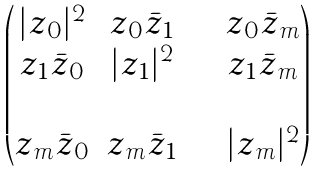Convert formula to latex. <formula><loc_0><loc_0><loc_500><loc_500>\begin{pmatrix} | z _ { 0 } | ^ { 2 } & z _ { 0 } \bar { z } _ { 1 } & \cdots & z _ { 0 } \bar { z } _ { m } \\ z _ { 1 } \bar { z } _ { 0 } & | z _ { 1 } | ^ { 2 } & \cdots & z _ { 1 } \bar { z } _ { m } \\ \cdots & \cdots & \cdots & \cdots \\ z _ { m } \bar { z } _ { 0 } & z _ { m } \bar { z } _ { 1 } & \cdots & | z _ { m } | ^ { 2 } \end{pmatrix}</formula> 